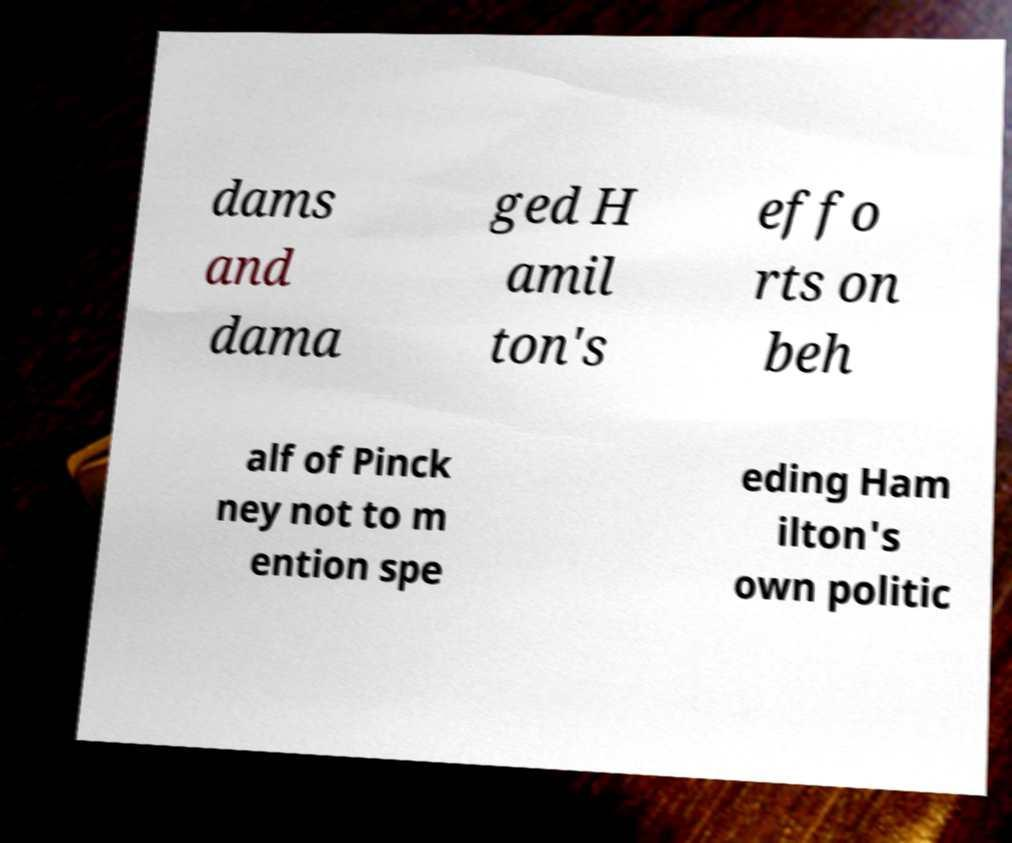For documentation purposes, I need the text within this image transcribed. Could you provide that? dams and dama ged H amil ton's effo rts on beh alf of Pinck ney not to m ention spe eding Ham ilton's own politic 